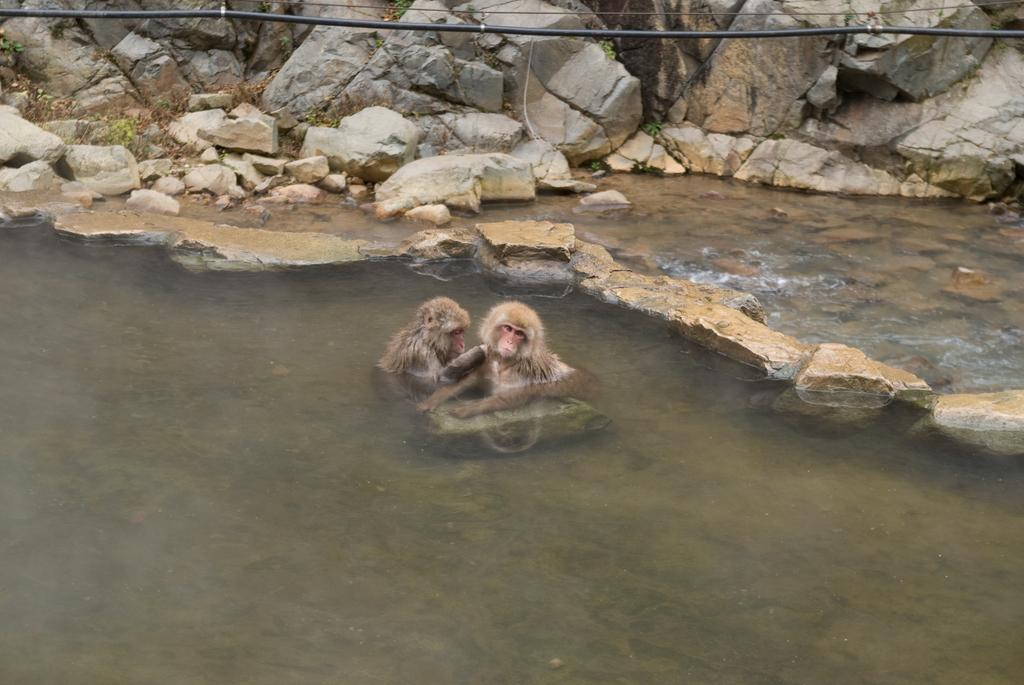How many monkeys are in the image? There are two monkeys in the image. What are the monkeys doing in the image? The monkeys are swimming in the water. What can be seen in the background of the image? There are rocks in the background of the image. What is the wire visible at the top of the image used for? The purpose of the wire visible at the top of the image is not clear from the facts provided. What type of stove can be seen in the image? There is no stove present in the image. What is the cause of the monkeys' swimming in the image? The cause of the monkeys' swimming in the image is not mentioned in the facts provided. 